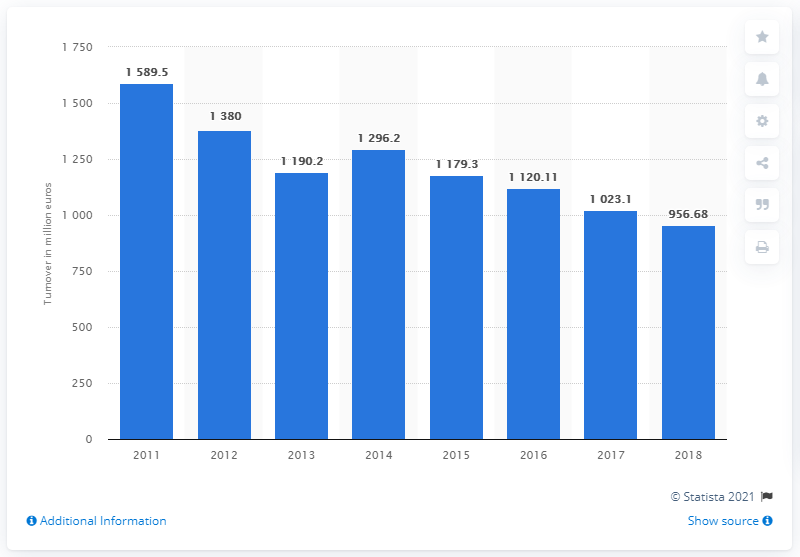Point out several critical features in this image. In 2018, the Benetton Group reported a decrease in turnover. The turnover of Benetton Group in 2011 was 1589.5 million. 